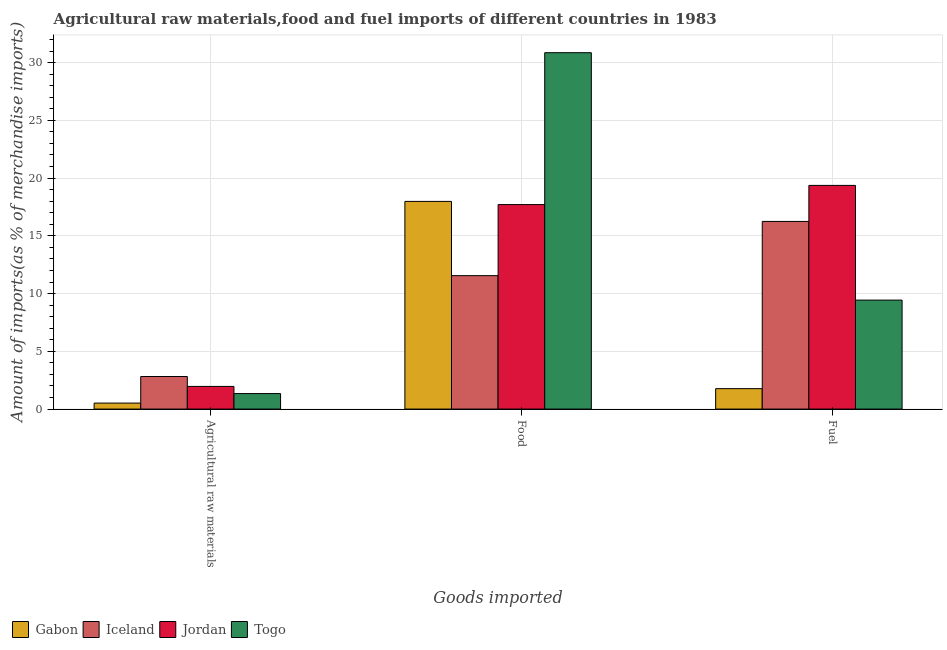How many different coloured bars are there?
Your answer should be compact. 4. Are the number of bars per tick equal to the number of legend labels?
Your answer should be very brief. Yes. What is the label of the 1st group of bars from the left?
Give a very brief answer. Agricultural raw materials. What is the percentage of raw materials imports in Iceland?
Give a very brief answer. 2.82. Across all countries, what is the maximum percentage of fuel imports?
Your answer should be very brief. 19.37. Across all countries, what is the minimum percentage of food imports?
Provide a succinct answer. 11.55. In which country was the percentage of food imports maximum?
Your answer should be compact. Togo. In which country was the percentage of fuel imports minimum?
Your response must be concise. Gabon. What is the total percentage of food imports in the graph?
Give a very brief answer. 78.1. What is the difference between the percentage of fuel imports in Iceland and that in Gabon?
Offer a terse response. 14.48. What is the difference between the percentage of raw materials imports in Iceland and the percentage of food imports in Gabon?
Give a very brief answer. -15.16. What is the average percentage of fuel imports per country?
Your answer should be compact. 11.7. What is the difference between the percentage of food imports and percentage of raw materials imports in Togo?
Ensure brevity in your answer.  29.51. In how many countries, is the percentage of fuel imports greater than 26 %?
Keep it short and to the point. 0. What is the ratio of the percentage of raw materials imports in Gabon to that in Jordan?
Your answer should be compact. 0.26. Is the percentage of fuel imports in Jordan less than that in Iceland?
Ensure brevity in your answer.  No. Is the difference between the percentage of fuel imports in Jordan and Gabon greater than the difference between the percentage of food imports in Jordan and Gabon?
Your answer should be compact. Yes. What is the difference between the highest and the second highest percentage of food imports?
Make the answer very short. 12.88. What is the difference between the highest and the lowest percentage of raw materials imports?
Offer a terse response. 2.3. What does the 4th bar from the right in Agricultural raw materials represents?
Provide a short and direct response. Gabon. How many bars are there?
Your answer should be compact. 12. How many countries are there in the graph?
Make the answer very short. 4. What is the difference between two consecutive major ticks on the Y-axis?
Give a very brief answer. 5. Does the graph contain any zero values?
Provide a short and direct response. No. Does the graph contain grids?
Offer a very short reply. Yes. Where does the legend appear in the graph?
Offer a very short reply. Bottom left. How are the legend labels stacked?
Provide a succinct answer. Horizontal. What is the title of the graph?
Your response must be concise. Agricultural raw materials,food and fuel imports of different countries in 1983. What is the label or title of the X-axis?
Your answer should be very brief. Goods imported. What is the label or title of the Y-axis?
Your answer should be very brief. Amount of imports(as % of merchandise imports). What is the Amount of imports(as % of merchandise imports) in Gabon in Agricultural raw materials?
Provide a succinct answer. 0.52. What is the Amount of imports(as % of merchandise imports) of Iceland in Agricultural raw materials?
Offer a terse response. 2.82. What is the Amount of imports(as % of merchandise imports) of Jordan in Agricultural raw materials?
Ensure brevity in your answer.  1.96. What is the Amount of imports(as % of merchandise imports) of Togo in Agricultural raw materials?
Give a very brief answer. 1.34. What is the Amount of imports(as % of merchandise imports) in Gabon in Food?
Give a very brief answer. 17.98. What is the Amount of imports(as % of merchandise imports) of Iceland in Food?
Your response must be concise. 11.55. What is the Amount of imports(as % of merchandise imports) in Jordan in Food?
Keep it short and to the point. 17.71. What is the Amount of imports(as % of merchandise imports) of Togo in Food?
Provide a succinct answer. 30.86. What is the Amount of imports(as % of merchandise imports) in Gabon in Fuel?
Your answer should be very brief. 1.77. What is the Amount of imports(as % of merchandise imports) in Iceland in Fuel?
Your answer should be compact. 16.25. What is the Amount of imports(as % of merchandise imports) in Jordan in Fuel?
Your answer should be compact. 19.37. What is the Amount of imports(as % of merchandise imports) in Togo in Fuel?
Give a very brief answer. 9.44. Across all Goods imported, what is the maximum Amount of imports(as % of merchandise imports) in Gabon?
Ensure brevity in your answer.  17.98. Across all Goods imported, what is the maximum Amount of imports(as % of merchandise imports) in Iceland?
Offer a terse response. 16.25. Across all Goods imported, what is the maximum Amount of imports(as % of merchandise imports) in Jordan?
Your response must be concise. 19.37. Across all Goods imported, what is the maximum Amount of imports(as % of merchandise imports) of Togo?
Your answer should be very brief. 30.86. Across all Goods imported, what is the minimum Amount of imports(as % of merchandise imports) in Gabon?
Make the answer very short. 0.52. Across all Goods imported, what is the minimum Amount of imports(as % of merchandise imports) in Iceland?
Give a very brief answer. 2.82. Across all Goods imported, what is the minimum Amount of imports(as % of merchandise imports) of Jordan?
Ensure brevity in your answer.  1.96. Across all Goods imported, what is the minimum Amount of imports(as % of merchandise imports) of Togo?
Your answer should be very brief. 1.34. What is the total Amount of imports(as % of merchandise imports) in Gabon in the graph?
Provide a short and direct response. 20.27. What is the total Amount of imports(as % of merchandise imports) in Iceland in the graph?
Provide a succinct answer. 30.62. What is the total Amount of imports(as % of merchandise imports) in Jordan in the graph?
Your response must be concise. 39.04. What is the total Amount of imports(as % of merchandise imports) of Togo in the graph?
Your answer should be very brief. 41.64. What is the difference between the Amount of imports(as % of merchandise imports) in Gabon in Agricultural raw materials and that in Food?
Ensure brevity in your answer.  -17.46. What is the difference between the Amount of imports(as % of merchandise imports) of Iceland in Agricultural raw materials and that in Food?
Provide a succinct answer. -8.73. What is the difference between the Amount of imports(as % of merchandise imports) of Jordan in Agricultural raw materials and that in Food?
Your answer should be compact. -15.74. What is the difference between the Amount of imports(as % of merchandise imports) in Togo in Agricultural raw materials and that in Food?
Provide a short and direct response. -29.51. What is the difference between the Amount of imports(as % of merchandise imports) of Gabon in Agricultural raw materials and that in Fuel?
Make the answer very short. -1.25. What is the difference between the Amount of imports(as % of merchandise imports) of Iceland in Agricultural raw materials and that in Fuel?
Give a very brief answer. -13.43. What is the difference between the Amount of imports(as % of merchandise imports) in Jordan in Agricultural raw materials and that in Fuel?
Give a very brief answer. -17.41. What is the difference between the Amount of imports(as % of merchandise imports) of Togo in Agricultural raw materials and that in Fuel?
Provide a short and direct response. -8.09. What is the difference between the Amount of imports(as % of merchandise imports) of Gabon in Food and that in Fuel?
Your answer should be very brief. 16.21. What is the difference between the Amount of imports(as % of merchandise imports) in Iceland in Food and that in Fuel?
Offer a terse response. -4.69. What is the difference between the Amount of imports(as % of merchandise imports) of Jordan in Food and that in Fuel?
Provide a succinct answer. -1.66. What is the difference between the Amount of imports(as % of merchandise imports) in Togo in Food and that in Fuel?
Give a very brief answer. 21.42. What is the difference between the Amount of imports(as % of merchandise imports) in Gabon in Agricultural raw materials and the Amount of imports(as % of merchandise imports) in Iceland in Food?
Offer a terse response. -11.03. What is the difference between the Amount of imports(as % of merchandise imports) of Gabon in Agricultural raw materials and the Amount of imports(as % of merchandise imports) of Jordan in Food?
Your answer should be very brief. -17.19. What is the difference between the Amount of imports(as % of merchandise imports) in Gabon in Agricultural raw materials and the Amount of imports(as % of merchandise imports) in Togo in Food?
Your answer should be compact. -30.34. What is the difference between the Amount of imports(as % of merchandise imports) of Iceland in Agricultural raw materials and the Amount of imports(as % of merchandise imports) of Jordan in Food?
Offer a terse response. -14.89. What is the difference between the Amount of imports(as % of merchandise imports) of Iceland in Agricultural raw materials and the Amount of imports(as % of merchandise imports) of Togo in Food?
Offer a very short reply. -28.04. What is the difference between the Amount of imports(as % of merchandise imports) of Jordan in Agricultural raw materials and the Amount of imports(as % of merchandise imports) of Togo in Food?
Your response must be concise. -28.89. What is the difference between the Amount of imports(as % of merchandise imports) of Gabon in Agricultural raw materials and the Amount of imports(as % of merchandise imports) of Iceland in Fuel?
Ensure brevity in your answer.  -15.73. What is the difference between the Amount of imports(as % of merchandise imports) in Gabon in Agricultural raw materials and the Amount of imports(as % of merchandise imports) in Jordan in Fuel?
Make the answer very short. -18.85. What is the difference between the Amount of imports(as % of merchandise imports) in Gabon in Agricultural raw materials and the Amount of imports(as % of merchandise imports) in Togo in Fuel?
Make the answer very short. -8.92. What is the difference between the Amount of imports(as % of merchandise imports) in Iceland in Agricultural raw materials and the Amount of imports(as % of merchandise imports) in Jordan in Fuel?
Your response must be concise. -16.55. What is the difference between the Amount of imports(as % of merchandise imports) in Iceland in Agricultural raw materials and the Amount of imports(as % of merchandise imports) in Togo in Fuel?
Make the answer very short. -6.62. What is the difference between the Amount of imports(as % of merchandise imports) of Jordan in Agricultural raw materials and the Amount of imports(as % of merchandise imports) of Togo in Fuel?
Keep it short and to the point. -7.47. What is the difference between the Amount of imports(as % of merchandise imports) of Gabon in Food and the Amount of imports(as % of merchandise imports) of Iceland in Fuel?
Provide a short and direct response. 1.73. What is the difference between the Amount of imports(as % of merchandise imports) of Gabon in Food and the Amount of imports(as % of merchandise imports) of Jordan in Fuel?
Offer a very short reply. -1.39. What is the difference between the Amount of imports(as % of merchandise imports) of Gabon in Food and the Amount of imports(as % of merchandise imports) of Togo in Fuel?
Your answer should be very brief. 8.55. What is the difference between the Amount of imports(as % of merchandise imports) in Iceland in Food and the Amount of imports(as % of merchandise imports) in Jordan in Fuel?
Offer a terse response. -7.82. What is the difference between the Amount of imports(as % of merchandise imports) of Iceland in Food and the Amount of imports(as % of merchandise imports) of Togo in Fuel?
Offer a very short reply. 2.12. What is the difference between the Amount of imports(as % of merchandise imports) of Jordan in Food and the Amount of imports(as % of merchandise imports) of Togo in Fuel?
Your answer should be compact. 8.27. What is the average Amount of imports(as % of merchandise imports) in Gabon per Goods imported?
Your response must be concise. 6.76. What is the average Amount of imports(as % of merchandise imports) of Iceland per Goods imported?
Ensure brevity in your answer.  10.21. What is the average Amount of imports(as % of merchandise imports) of Jordan per Goods imported?
Make the answer very short. 13.01. What is the average Amount of imports(as % of merchandise imports) of Togo per Goods imported?
Your response must be concise. 13.88. What is the difference between the Amount of imports(as % of merchandise imports) of Gabon and Amount of imports(as % of merchandise imports) of Iceland in Agricultural raw materials?
Offer a terse response. -2.3. What is the difference between the Amount of imports(as % of merchandise imports) of Gabon and Amount of imports(as % of merchandise imports) of Jordan in Agricultural raw materials?
Give a very brief answer. -1.44. What is the difference between the Amount of imports(as % of merchandise imports) in Gabon and Amount of imports(as % of merchandise imports) in Togo in Agricultural raw materials?
Make the answer very short. -0.82. What is the difference between the Amount of imports(as % of merchandise imports) in Iceland and Amount of imports(as % of merchandise imports) in Jordan in Agricultural raw materials?
Your answer should be compact. 0.86. What is the difference between the Amount of imports(as % of merchandise imports) of Iceland and Amount of imports(as % of merchandise imports) of Togo in Agricultural raw materials?
Provide a short and direct response. 1.48. What is the difference between the Amount of imports(as % of merchandise imports) in Jordan and Amount of imports(as % of merchandise imports) in Togo in Agricultural raw materials?
Your answer should be very brief. 0.62. What is the difference between the Amount of imports(as % of merchandise imports) of Gabon and Amount of imports(as % of merchandise imports) of Iceland in Food?
Keep it short and to the point. 6.43. What is the difference between the Amount of imports(as % of merchandise imports) in Gabon and Amount of imports(as % of merchandise imports) in Jordan in Food?
Give a very brief answer. 0.28. What is the difference between the Amount of imports(as % of merchandise imports) in Gabon and Amount of imports(as % of merchandise imports) in Togo in Food?
Keep it short and to the point. -12.88. What is the difference between the Amount of imports(as % of merchandise imports) in Iceland and Amount of imports(as % of merchandise imports) in Jordan in Food?
Make the answer very short. -6.15. What is the difference between the Amount of imports(as % of merchandise imports) of Iceland and Amount of imports(as % of merchandise imports) of Togo in Food?
Make the answer very short. -19.3. What is the difference between the Amount of imports(as % of merchandise imports) of Jordan and Amount of imports(as % of merchandise imports) of Togo in Food?
Provide a short and direct response. -13.15. What is the difference between the Amount of imports(as % of merchandise imports) of Gabon and Amount of imports(as % of merchandise imports) of Iceland in Fuel?
Give a very brief answer. -14.48. What is the difference between the Amount of imports(as % of merchandise imports) of Gabon and Amount of imports(as % of merchandise imports) of Jordan in Fuel?
Provide a short and direct response. -17.6. What is the difference between the Amount of imports(as % of merchandise imports) of Gabon and Amount of imports(as % of merchandise imports) of Togo in Fuel?
Your response must be concise. -7.67. What is the difference between the Amount of imports(as % of merchandise imports) of Iceland and Amount of imports(as % of merchandise imports) of Jordan in Fuel?
Offer a very short reply. -3.12. What is the difference between the Amount of imports(as % of merchandise imports) of Iceland and Amount of imports(as % of merchandise imports) of Togo in Fuel?
Provide a short and direct response. 6.81. What is the difference between the Amount of imports(as % of merchandise imports) in Jordan and Amount of imports(as % of merchandise imports) in Togo in Fuel?
Offer a terse response. 9.93. What is the ratio of the Amount of imports(as % of merchandise imports) in Gabon in Agricultural raw materials to that in Food?
Provide a short and direct response. 0.03. What is the ratio of the Amount of imports(as % of merchandise imports) of Iceland in Agricultural raw materials to that in Food?
Provide a succinct answer. 0.24. What is the ratio of the Amount of imports(as % of merchandise imports) of Jordan in Agricultural raw materials to that in Food?
Your answer should be very brief. 0.11. What is the ratio of the Amount of imports(as % of merchandise imports) in Togo in Agricultural raw materials to that in Food?
Ensure brevity in your answer.  0.04. What is the ratio of the Amount of imports(as % of merchandise imports) in Gabon in Agricultural raw materials to that in Fuel?
Offer a terse response. 0.29. What is the ratio of the Amount of imports(as % of merchandise imports) in Iceland in Agricultural raw materials to that in Fuel?
Offer a terse response. 0.17. What is the ratio of the Amount of imports(as % of merchandise imports) of Jordan in Agricultural raw materials to that in Fuel?
Offer a terse response. 0.1. What is the ratio of the Amount of imports(as % of merchandise imports) in Togo in Agricultural raw materials to that in Fuel?
Make the answer very short. 0.14. What is the ratio of the Amount of imports(as % of merchandise imports) in Gabon in Food to that in Fuel?
Make the answer very short. 10.17. What is the ratio of the Amount of imports(as % of merchandise imports) of Iceland in Food to that in Fuel?
Give a very brief answer. 0.71. What is the ratio of the Amount of imports(as % of merchandise imports) of Jordan in Food to that in Fuel?
Provide a succinct answer. 0.91. What is the ratio of the Amount of imports(as % of merchandise imports) of Togo in Food to that in Fuel?
Provide a short and direct response. 3.27. What is the difference between the highest and the second highest Amount of imports(as % of merchandise imports) of Gabon?
Offer a terse response. 16.21. What is the difference between the highest and the second highest Amount of imports(as % of merchandise imports) in Iceland?
Keep it short and to the point. 4.69. What is the difference between the highest and the second highest Amount of imports(as % of merchandise imports) in Jordan?
Your answer should be very brief. 1.66. What is the difference between the highest and the second highest Amount of imports(as % of merchandise imports) in Togo?
Make the answer very short. 21.42. What is the difference between the highest and the lowest Amount of imports(as % of merchandise imports) in Gabon?
Keep it short and to the point. 17.46. What is the difference between the highest and the lowest Amount of imports(as % of merchandise imports) in Iceland?
Provide a short and direct response. 13.43. What is the difference between the highest and the lowest Amount of imports(as % of merchandise imports) of Jordan?
Offer a terse response. 17.41. What is the difference between the highest and the lowest Amount of imports(as % of merchandise imports) in Togo?
Ensure brevity in your answer.  29.51. 